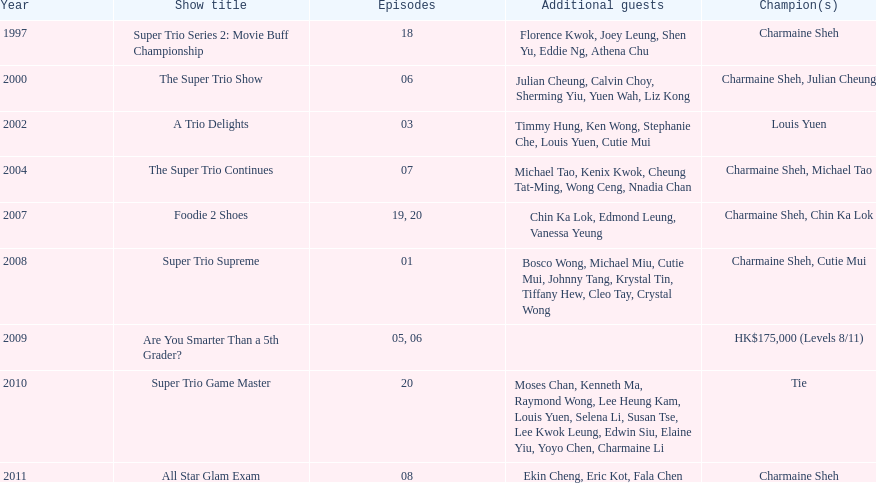How long has it been since chermaine sheh first appeared on a variety show? 17 years. 